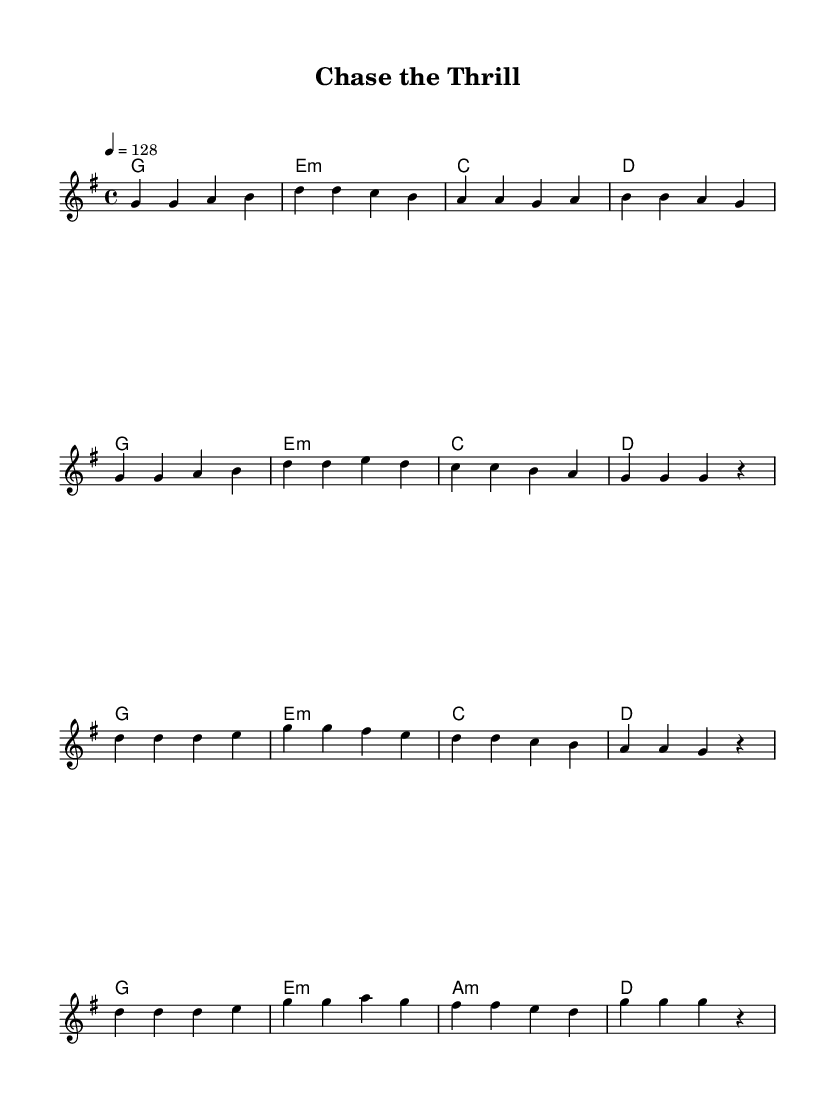What is the key signature of this music? The key signature is G major, which has one sharp (F#). This can be identified from the beginning of the sheet music where the key is indicated.
Answer: G major What is the time signature of this music? The time signature is 4/4, which is indicated at the beginning of the score. This means there are 4 beats in each measure and the quarter note gets one beat.
Answer: 4/4 What is the tempo marking for this music? The tempo marking is 128 beats per minute, indicated by the tempo text "4 = 128" at the start of the piece. This indicates how fast the piece should be played.
Answer: 128 How many measures are in the verse section? There are 8 measures in the verse section, which can be counted from the melody notation segment labeled as "Verse." Each line of music contains 4 measures, and there are two lines.
Answer: 8 What type of harmony is used in the chorus? The harmony used in the chorus includes minor chords, as seen in the e minor and a minor chords listed in the harmonic section for this part. This characteristic is common in K-Pop to create emotional tension.
Answer: Minor chords What is the last note of the melody? The last note of the melody is a "r," which stands for a rest indicating silence rather than a pitch, found at the end of the melody section.
Answer: r How many times is the note "d" played in the chorus? The note "d" is played 6 times in the chorus section, as counted from the melody line under the section labeled "Chorus." Each occurrence can be noted in the series of notes provided.
Answer: 6 